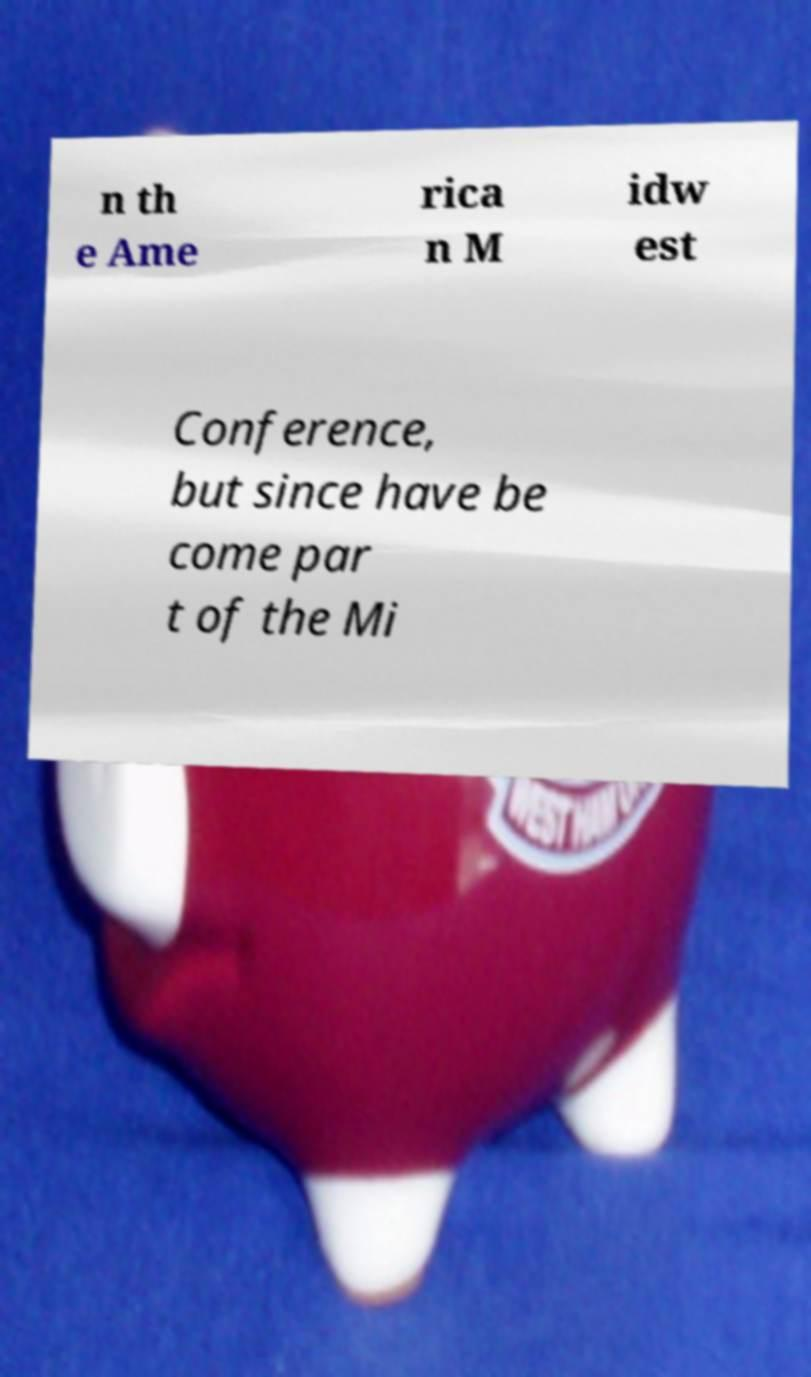Can you accurately transcribe the text from the provided image for me? n th e Ame rica n M idw est Conference, but since have be come par t of the Mi 